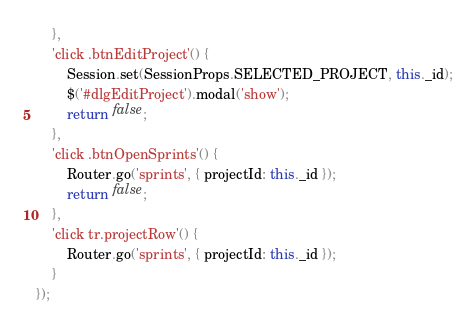Convert code to text. <code><loc_0><loc_0><loc_500><loc_500><_JavaScript_>    },
    'click .btnEditProject'() {
        Session.set(SessionProps.SELECTED_PROJECT, this._id);
        $('#dlgEditProject').modal('show');
        return false;
    },
    'click .btnOpenSprints'() {
        Router.go('sprints', { projectId: this._id });
        return false;
    },
    'click tr.projectRow'() {
        Router.go('sprints', { projectId: this._id });
    }
});</code> 